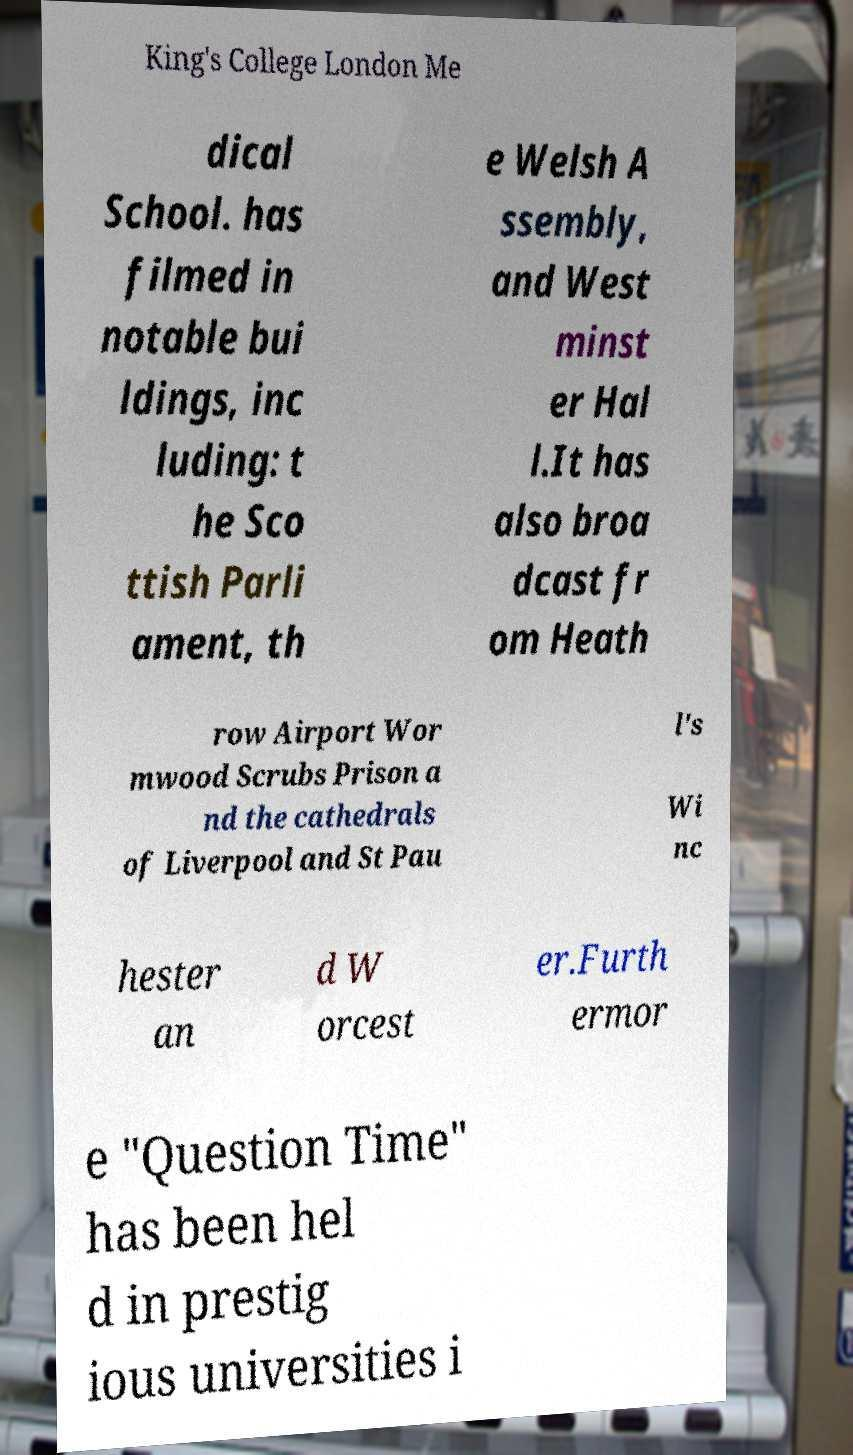What messages or text are displayed in this image? I need them in a readable, typed format. King's College London Me dical School. has filmed in notable bui ldings, inc luding: t he Sco ttish Parli ament, th e Welsh A ssembly, and West minst er Hal l.It has also broa dcast fr om Heath row Airport Wor mwood Scrubs Prison a nd the cathedrals of Liverpool and St Pau l's Wi nc hester an d W orcest er.Furth ermor e "Question Time" has been hel d in prestig ious universities i 